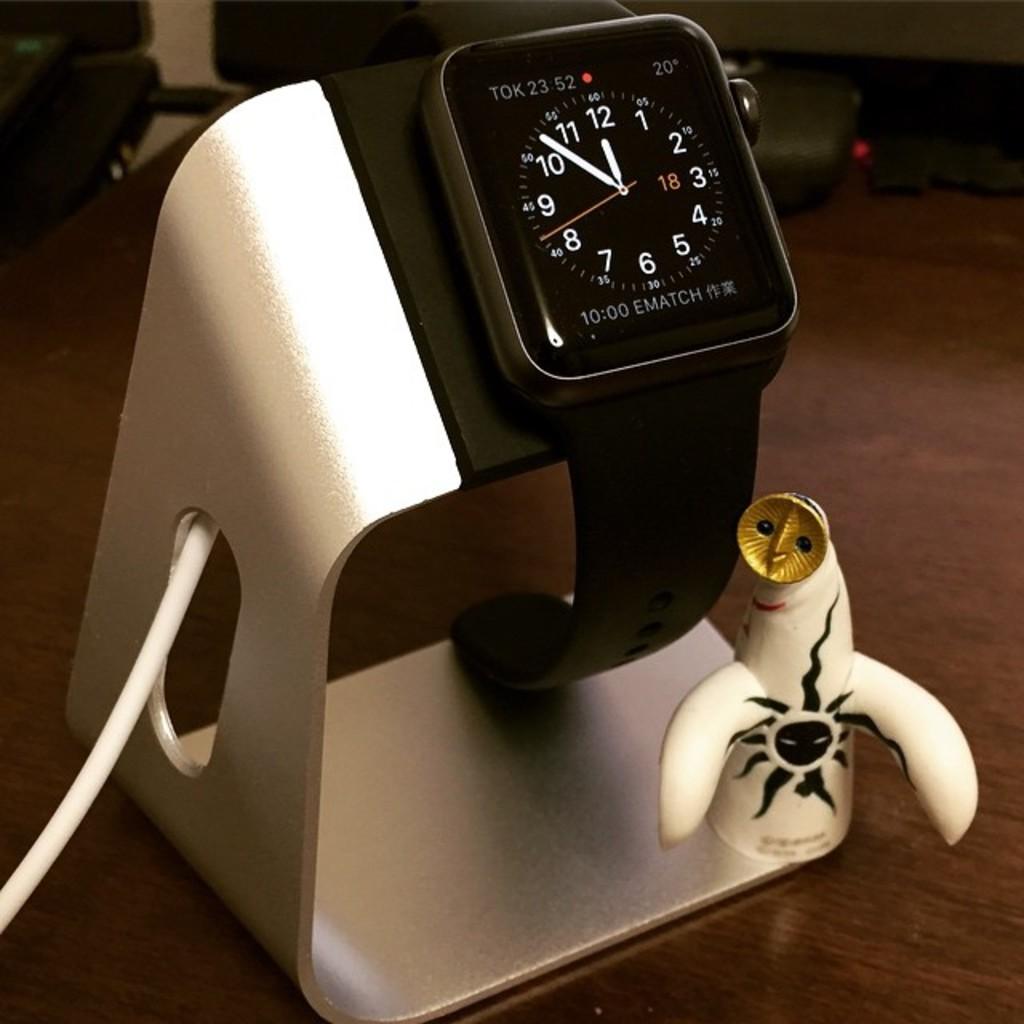What time does the clock display?
Ensure brevity in your answer.  11:53. 